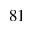Convert formula to latex. <formula><loc_0><loc_0><loc_500><loc_500>_ { 8 1 }</formula> 